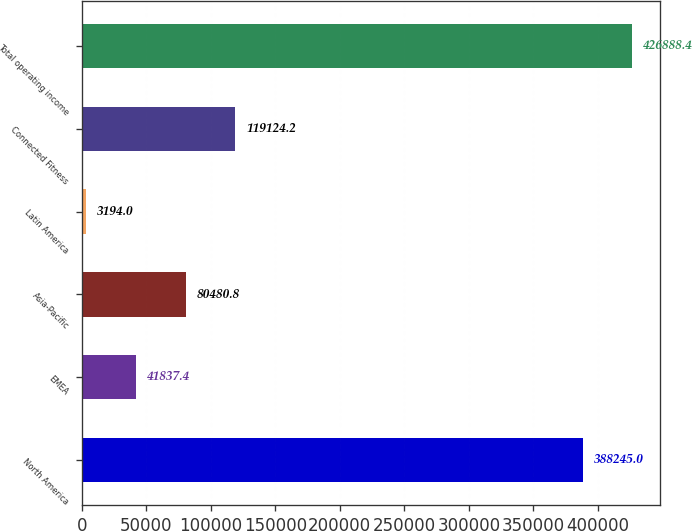Convert chart. <chart><loc_0><loc_0><loc_500><loc_500><bar_chart><fcel>North America<fcel>EMEA<fcel>Asia-Pacific<fcel>Latin America<fcel>Connected Fitness<fcel>Total operating income<nl><fcel>388245<fcel>41837.4<fcel>80480.8<fcel>3194<fcel>119124<fcel>426888<nl></chart> 